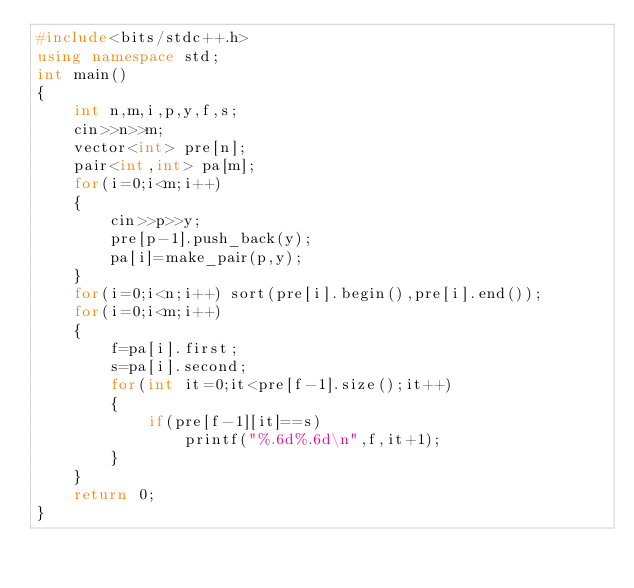Convert code to text. <code><loc_0><loc_0><loc_500><loc_500><_C++_>#include<bits/stdc++.h>
using namespace std;
int main()
{
    int n,m,i,p,y,f,s;
    cin>>n>>m;
    vector<int> pre[n];
    pair<int,int> pa[m];
    for(i=0;i<m;i++)
    {
        cin>>p>>y;
        pre[p-1].push_back(y);
        pa[i]=make_pair(p,y);
    }
    for(i=0;i<n;i++) sort(pre[i].begin(),pre[i].end());
    for(i=0;i<m;i++)
    {
        f=pa[i].first;
        s=pa[i].second;
        for(int it=0;it<pre[f-1].size();it++)
        {
            if(pre[f-1][it]==s)
                printf("%.6d%.6d\n",f,it+1);
        }
    }
    return 0;
}
</code> 